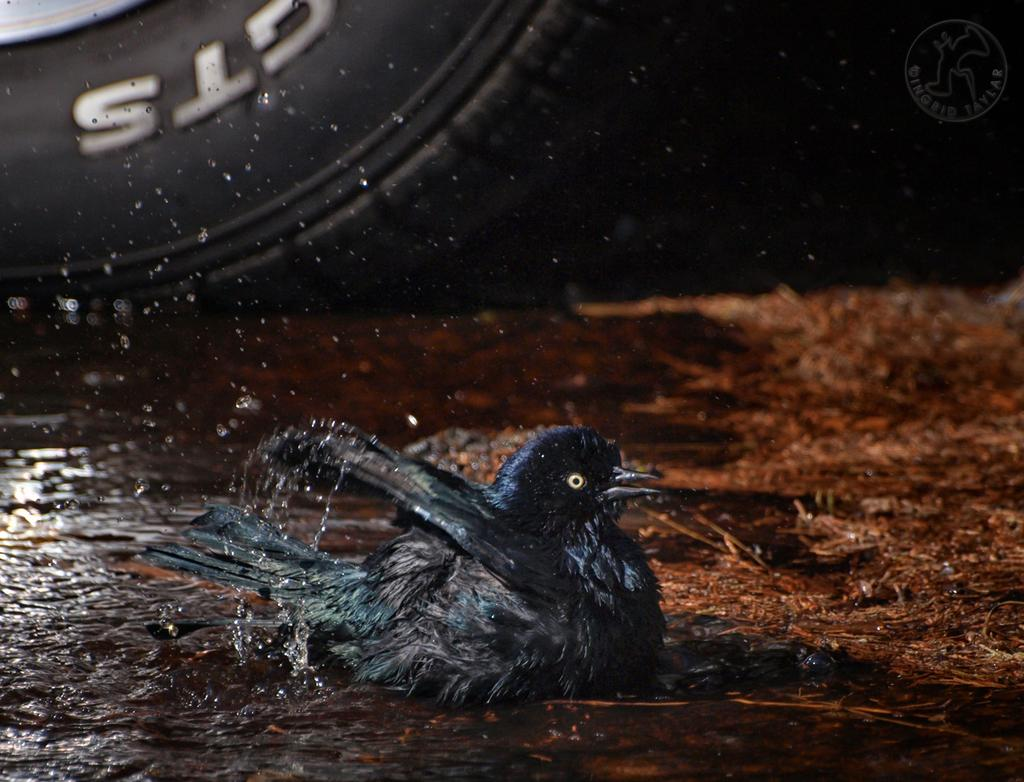What type of bird can be seen in the image? There is a black color bird in the image. What is the bird situated in? The bird is situated in water, which is visible in the image. What color is the tier in the image? There is a black color tier in the image. What is the color of the floor in the image? There is a brown floor in the image. What type of lipstick is the bird wearing in the image? There is no lipstick or indication of makeup on the bird in the image. 